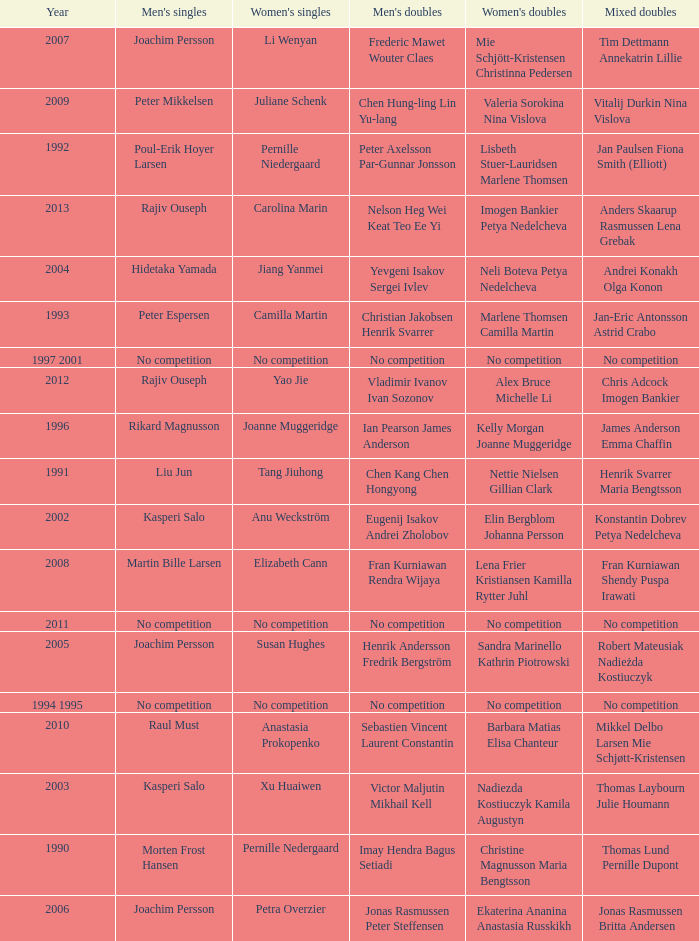Who won the Mixed Doubles in 2007? Tim Dettmann Annekatrin Lillie. 